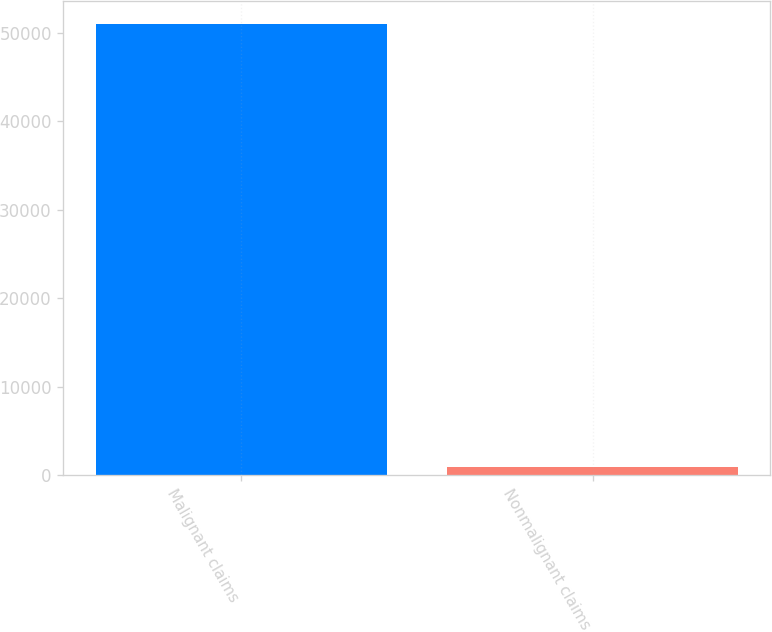Convert chart. <chart><loc_0><loc_0><loc_500><loc_500><bar_chart><fcel>Malignant claims<fcel>Nonmalignant claims<nl><fcel>51000<fcel>850<nl></chart> 